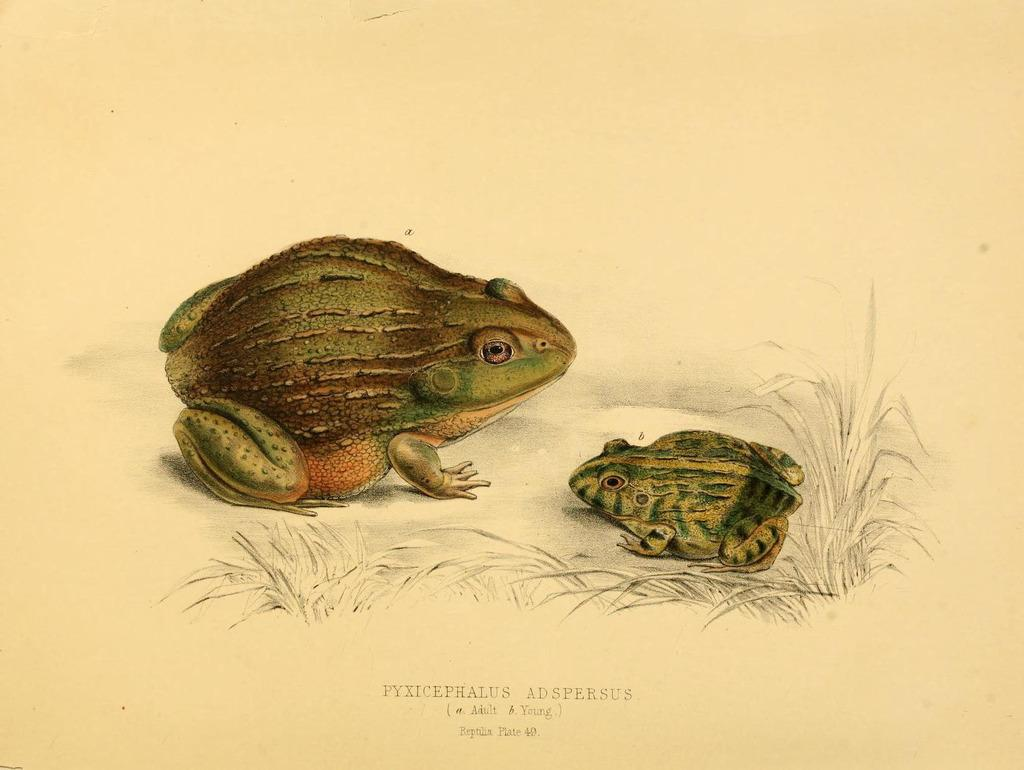What animals are in the middle of the image? There are two frogs in the middle of the image. What type of vegetation is at the bottom of the image? There are plants at the bottom of the image. What else can be found in the image besides the frogs and plants? There is text in the image. How does the yarn affect the frogs in the image? There is no yarn present in the image, so it cannot affect the frogs. 